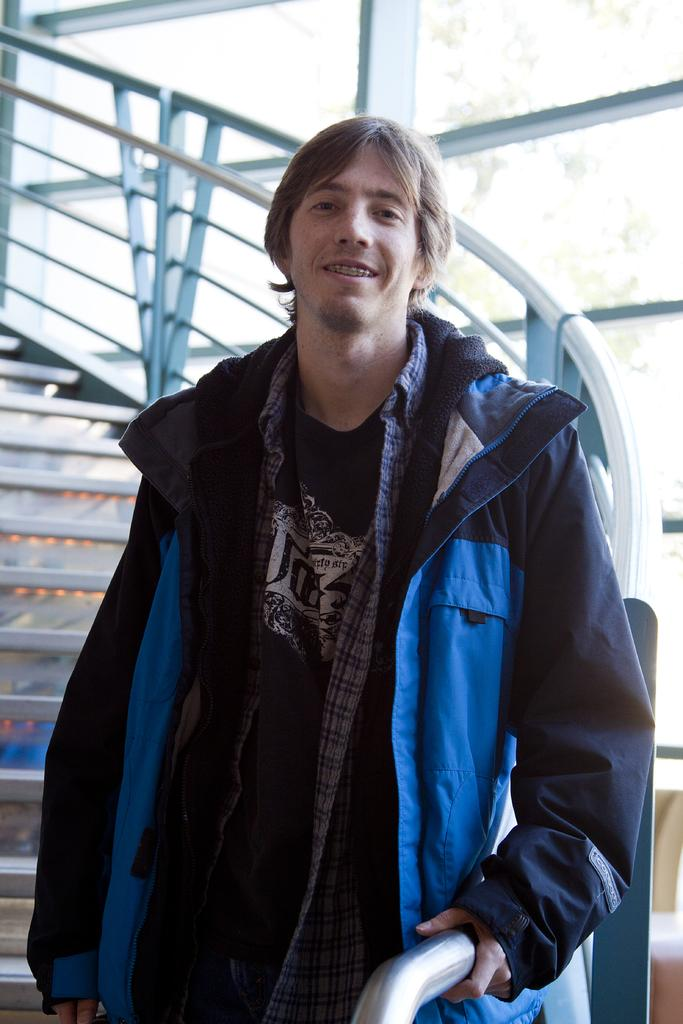What type of architectural feature is present in the image? There are stairs in the image. What can be seen through the windows in the image? There are windows in the image, but the view through them is not specified. Who is present in the image? There is a man in the image. What is the man wearing in the image? The man is wearing a black and blue color jacket. Is the man's pet visible in the image? There is no mention of a pet in the image, so it cannot be determined if one is present. What type of room is the man in, based on the image? The provided facts do not specify the type of room the man is in, so it cannot be determined from the image. 